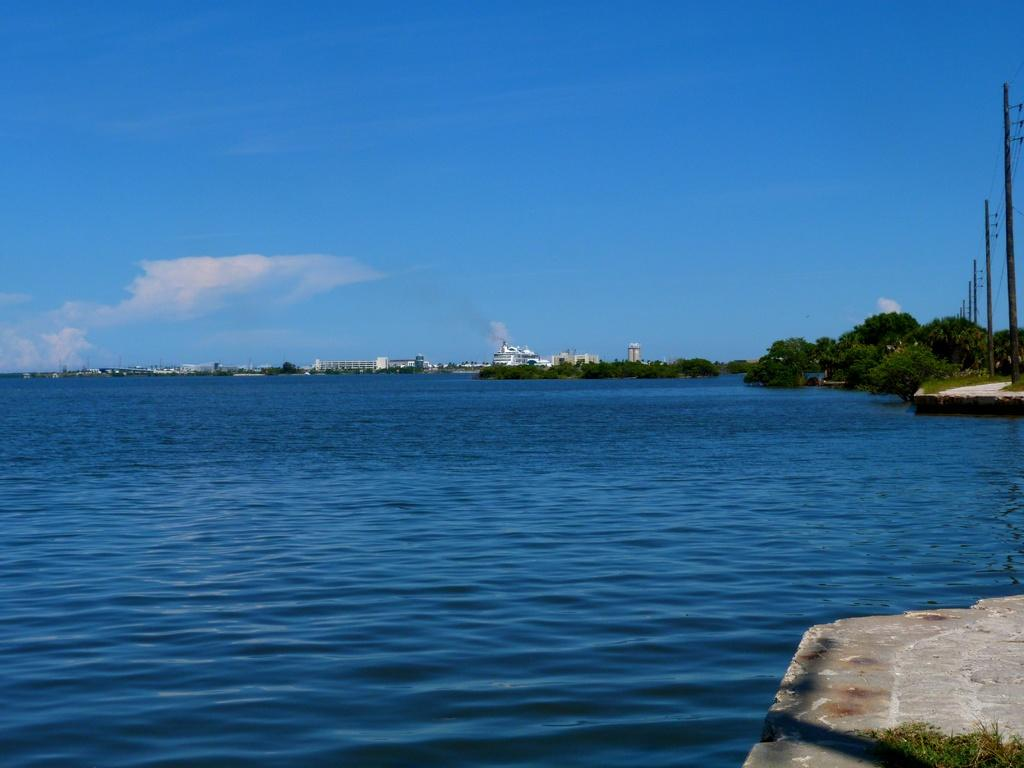What type of surface can be seen in the image? Ground is visible in the image. What type of vegetation is present in the image? There is grass in the image. What natural element is visible in the image? Water is visible in the image. What can be seen in the distance in the image? There are trees, black colored poles, buildings, and the sky visible in the background of the image. What appliance is being used by the laborer in the image? There is no laborer or appliance present in the image. How does the digestion process of the trees in the image work? Trees do not have a digestion process, as they are plants and not living organisms with digestive systems. 